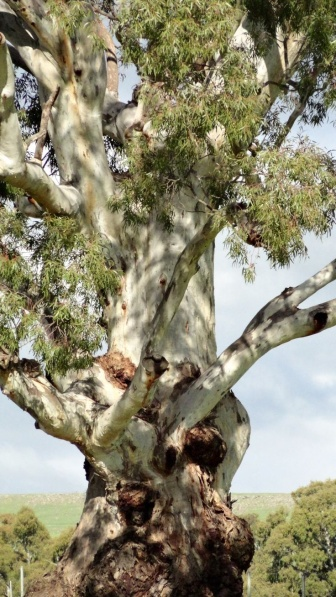What might be the significance of the large burls seen on this tree? The burls, or large protruding growths, on the tree's trunk and branches often form in response to stress, such as injury, fungal infection, or an insect infestation. While they may indicate past duress, burls are also signs of the tree's adaptive abilities and healing processes. Ecologically, they may provide habitats for various species, contributing to the biodiversity of the area. In woodworking, burls are prized for their intricate grain patterns, making this tree not just a symbol of resilience, but potentially a bearer of unique natural art as well. 